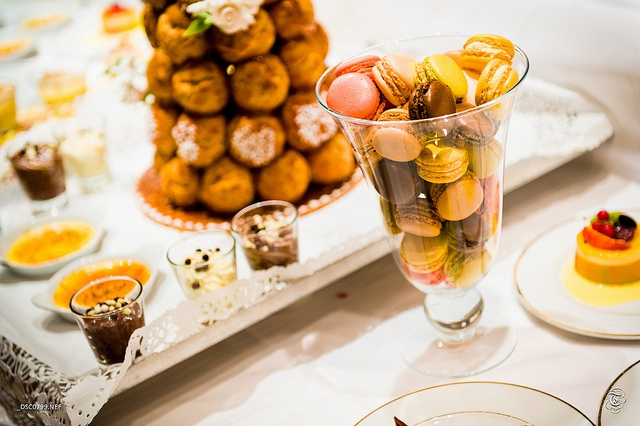Describe the objects in this image and their specific colors. I can see dining table in lightgray, tan, brown, and orange tones, wine glass in lightgray, orange, and tan tones, cup in lightgray, orange, and tan tones, cake in lightgray, orange, khaki, gold, and red tones, and bowl in lightgray, tan, orange, beige, and gold tones in this image. 